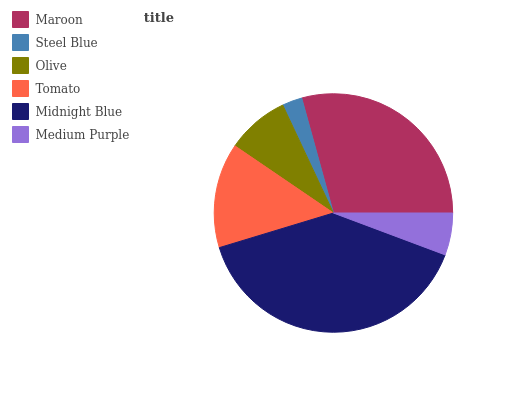Is Steel Blue the minimum?
Answer yes or no. Yes. Is Midnight Blue the maximum?
Answer yes or no. Yes. Is Olive the minimum?
Answer yes or no. No. Is Olive the maximum?
Answer yes or no. No. Is Olive greater than Steel Blue?
Answer yes or no. Yes. Is Steel Blue less than Olive?
Answer yes or no. Yes. Is Steel Blue greater than Olive?
Answer yes or no. No. Is Olive less than Steel Blue?
Answer yes or no. No. Is Tomato the high median?
Answer yes or no. Yes. Is Olive the low median?
Answer yes or no. Yes. Is Medium Purple the high median?
Answer yes or no. No. Is Midnight Blue the low median?
Answer yes or no. No. 